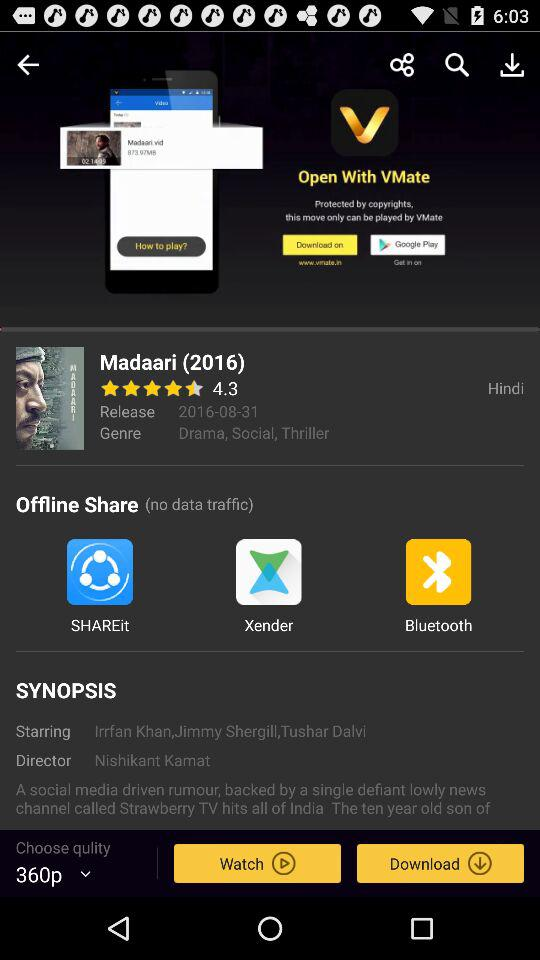What is the name of the movie? The name of the movie is "Madaari". 